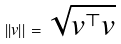<formula> <loc_0><loc_0><loc_500><loc_500>| | v | | = \sqrt { v ^ { \top } v }</formula> 